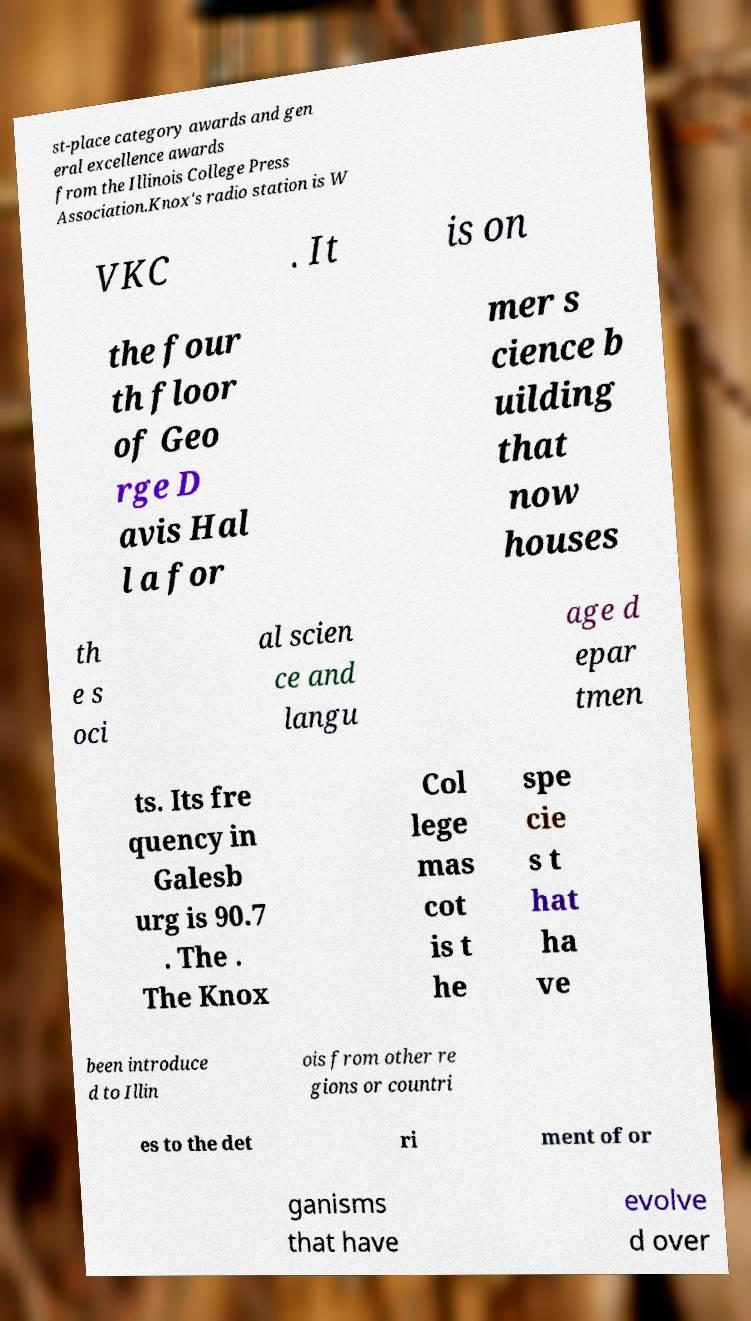Please identify and transcribe the text found in this image. st-place category awards and gen eral excellence awards from the Illinois College Press Association.Knox's radio station is W VKC . It is on the four th floor of Geo rge D avis Hal l a for mer s cience b uilding that now houses th e s oci al scien ce and langu age d epar tmen ts. Its fre quency in Galesb urg is 90.7 . The . The Knox Col lege mas cot is t he spe cie s t hat ha ve been introduce d to Illin ois from other re gions or countri es to the det ri ment of or ganisms that have evolve d over 